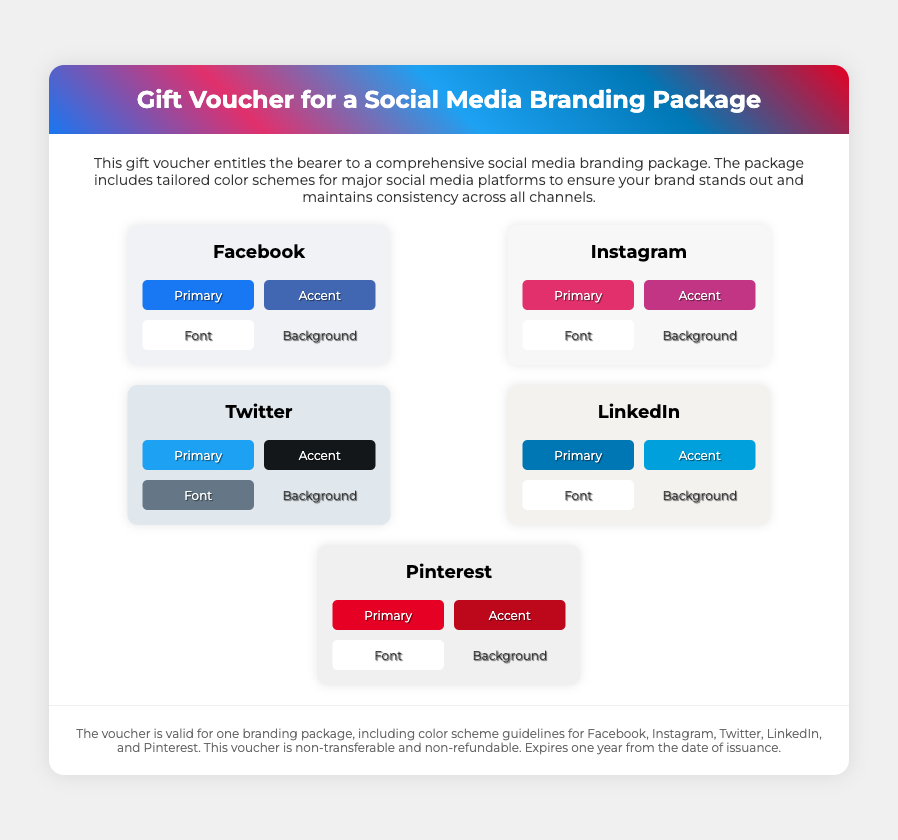What is the title of the voucher? The title of the voucher is displayed prominently at the top of the document.
Answer: Gift Voucher for a Social Media Branding Package How many social media platforms are included? The platforms listed in the document indicate how many branding guidelines are covered.
Answer: Five What color represents Facebook's primary color? Facebook's primary color is specified in the color grid under the Facebook section.
Answer: #1877F2 Which color is used for the background of the Pinterest section? The background color of the Pinterest platform is mentioned in the document.
Answer: #F0F0F0 What is the validity period for the voucher? The expiration date for the voucher is mentioned in the fine print section of the document.
Answer: One year What is included in the social media branding package? The description section outlines what the package consists of regarding branding.
Answer: Tailored color schemes What is the accent color for Instagram? The accent color for Instagram is listed in the color grid for that platform.
Answer: #C13584 Is the voucher transferable? The fine print clarifies the terms of use for the voucher.
Answer: Non-transferable What color is the font in the Twitter section? The font color for Twitter is detailed in its respective color grid.
Answer: #657786 